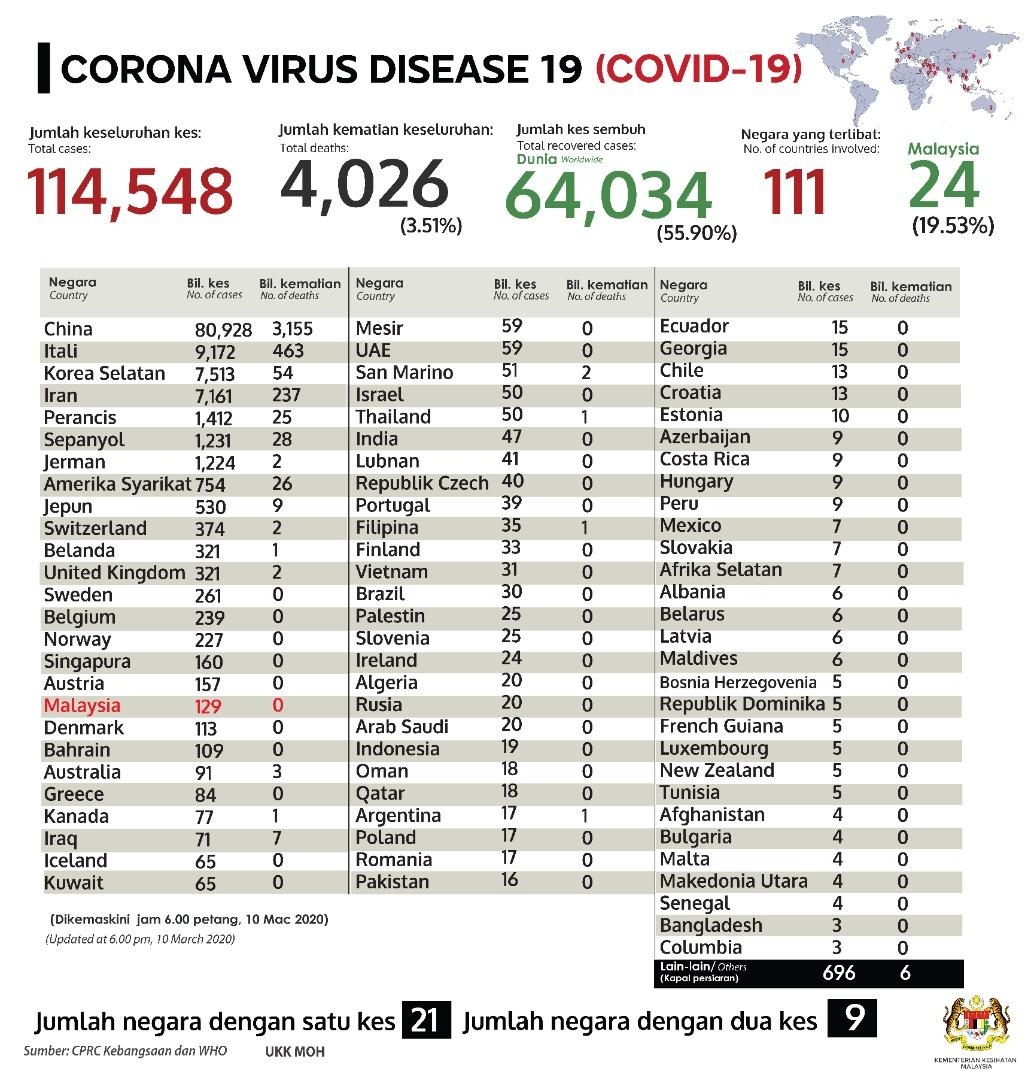Mention a couple of crucial points in this snapshot. The difference between the total number of cases that were fully recovered and the total number of deaths is 52.39%. The total cases and total recovered cases refer to the number of individuals who have been affected by a particular situation, with the total cases including those who have been fully recovered and those who are still being treated, while the total recovered cases only include individuals who have been fully recovered and are no longer being treated. In the example provided, the total cases are 50,514, and the total recovered cases are 323. The difference between the number of cases and number of deaths in Iraq is 64. In Thailand, there is a significant difference between the number of cases and the number of deaths. Specifically, there are 49 cases while the number of deaths is 49. In 2020, there were a total of 110,522 reported cases of COVID-19 in Japan, and a total of 110,321 deaths. 